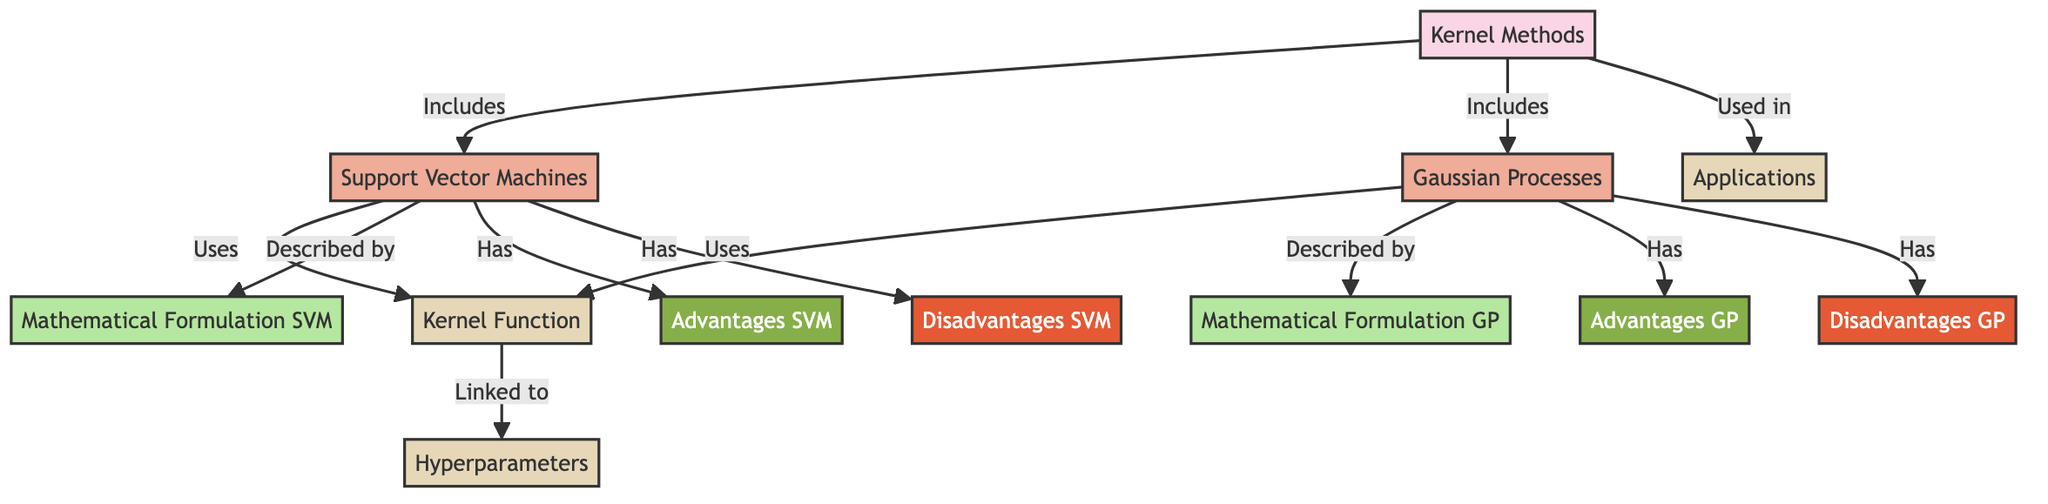What are the two main methods included in the kernel methods? The diagram states that the two main methods under "Kernel Methods" are "Support Vector Machines" and "Gaussian Processes." This can be seen as the nodes directly connected to the "Kernel Methods" node.
Answer: Support Vector Machines, Gaussian Processes What common factor is used by both Support Vector Machines and Gaussian Processes? Both methods utilize a "Kernel Function," as indicated by the arrows linking the methods to the common node. This highlights that "Kernel Function" is essential for both.
Answer: Kernel Function How many advantages does Support Vector Machines have according to the diagram? By counting the nodes directly under "Support Vector Machines," there are two advantages listed, which are connected from the "Has" relationship in the diagram.
Answer: 2 What is a key difference in the mathematical formulation between Support Vector Machines and Gaussian Processes? The diagram represents "Mathematical Formulation SVM" specifically for Support Vector Machines and "Mathematical Formulation GP" specifically for Gaussian Processes. This indicates that the mathematical formulation is unique for each method.
Answer: Unique formulations What applications are linked to kernel methods in the diagram? The "Applications" node is connected to the "Kernel Methods" node through the "Used in" relationship, indicating that kernel methods have relevant applications. The specific applications are not detailed in the nodes, but their usage is highlighted.
Answer: Applications mentioned Which method has a disadvantage related to overfitting according to the diagram? Looking at the disadvantages listed under "Support Vector Machines" and "Gaussian Processes," it is implied that "Disadvantages SVM" highlights a risk of overfitting, as seen in typical descriptions of SVMs.
Answer: Support Vector Machines What is the relationship between Kernel Function and Hyperparameters in this diagram? The "Kernel Function" node indicates it is linked to "Hyperparameters" through a connection in the diagram, illustrating that kernel functions are associated with tuning hyperparameters in both methods.
Answer: Linked How many disadvantages are associated with Gaussian Processes? The diagram shows two disadvantages listed directly under "Gaussian Processes," thus indicating the total count for that method specifically.
Answer: 2 